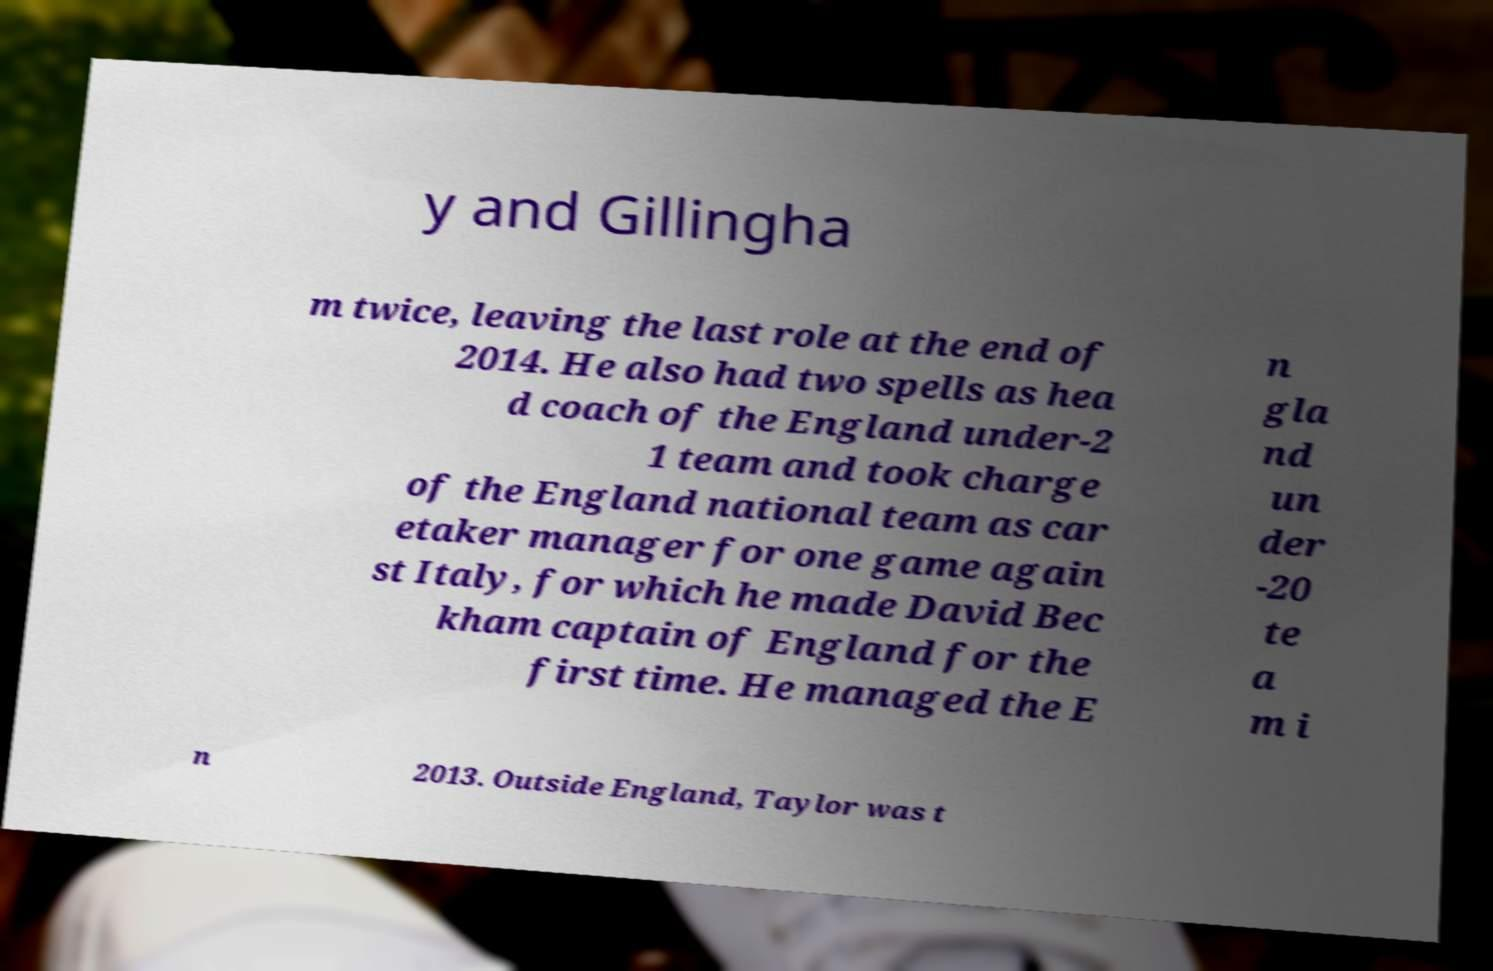What messages or text are displayed in this image? I need them in a readable, typed format. y and Gillingha m twice, leaving the last role at the end of 2014. He also had two spells as hea d coach of the England under-2 1 team and took charge of the England national team as car etaker manager for one game again st Italy, for which he made David Bec kham captain of England for the first time. He managed the E n gla nd un der -20 te a m i n 2013. Outside England, Taylor was t 